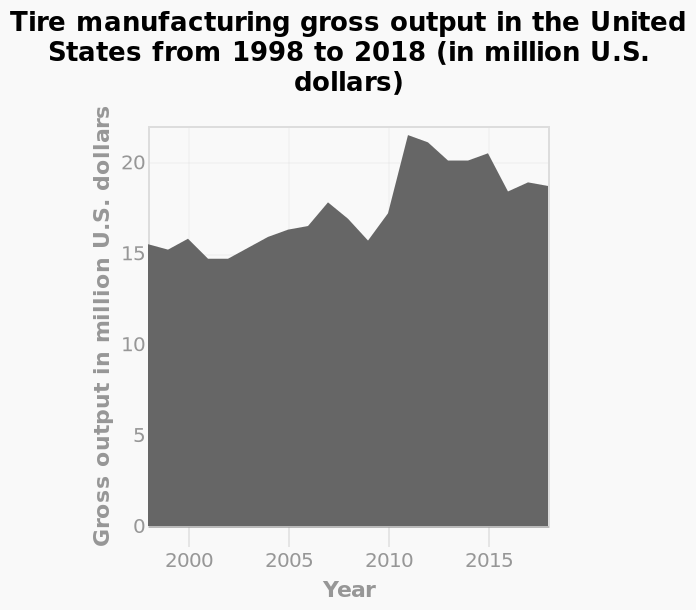<image>
Does the chart provide any information about the reasons for the upward trend between 2009 and 2011?  No, the chart does not provide any specific information about the reasons for the upward trend between 2009 and 2011. What is the general trend of gross output?  The general trend of gross output is upwards. What is measured along the x-axis?  Year is measured along the x-axis. please enumerates aspects of the construction of the chart This area graph is titled Tire manufacturing gross output in the United States from 1998 to 2018 (in million U.S. dollars). Along the x-axis, Year is measured. There is a linear scale with a minimum of 0 and a maximum of 20 on the y-axis, labeled Gross output in million U.S. dollars. What is the trend in output between 2015 and 2017? Although the overall trend is upwards, the output has reduced between 2015 and 2017. 